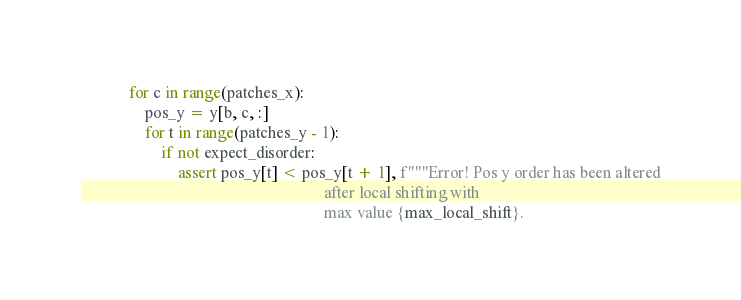<code> <loc_0><loc_0><loc_500><loc_500><_Python_>            for c in range(patches_x):
                pos_y = y[b, c, :]
                for t in range(patches_y - 1):
                    if not expect_disorder:
                        assert pos_y[t] < pos_y[t + 1], f"""Error! Pos y order has been altered
                                                            after local shifting with
                                                            max value {max_local_shift}.</code> 